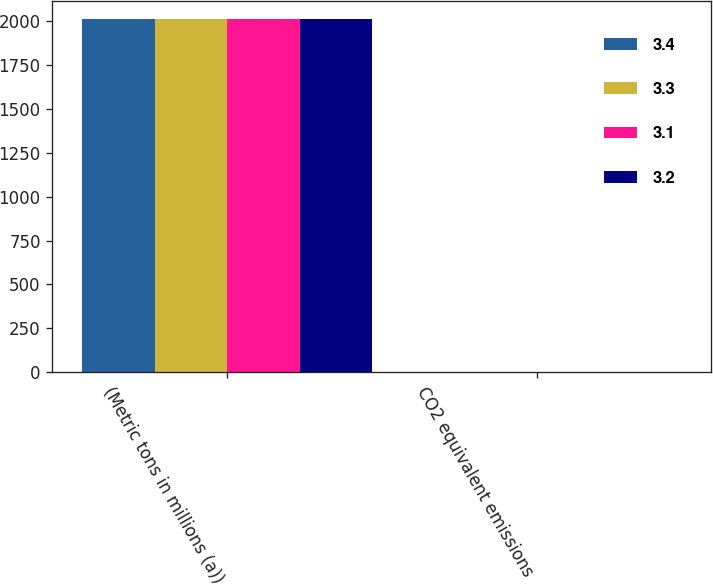Convert chart to OTSL. <chart><loc_0><loc_0><loc_500><loc_500><stacked_bar_chart><ecel><fcel>(Metric tons in millions (a))<fcel>CO2 equivalent emissions<nl><fcel>3.4<fcel>2012<fcel>3.3<nl><fcel>3.3<fcel>2013<fcel>3.4<nl><fcel>3.1<fcel>2014<fcel>3.2<nl><fcel>3.2<fcel>2016<fcel>3.1<nl></chart> 